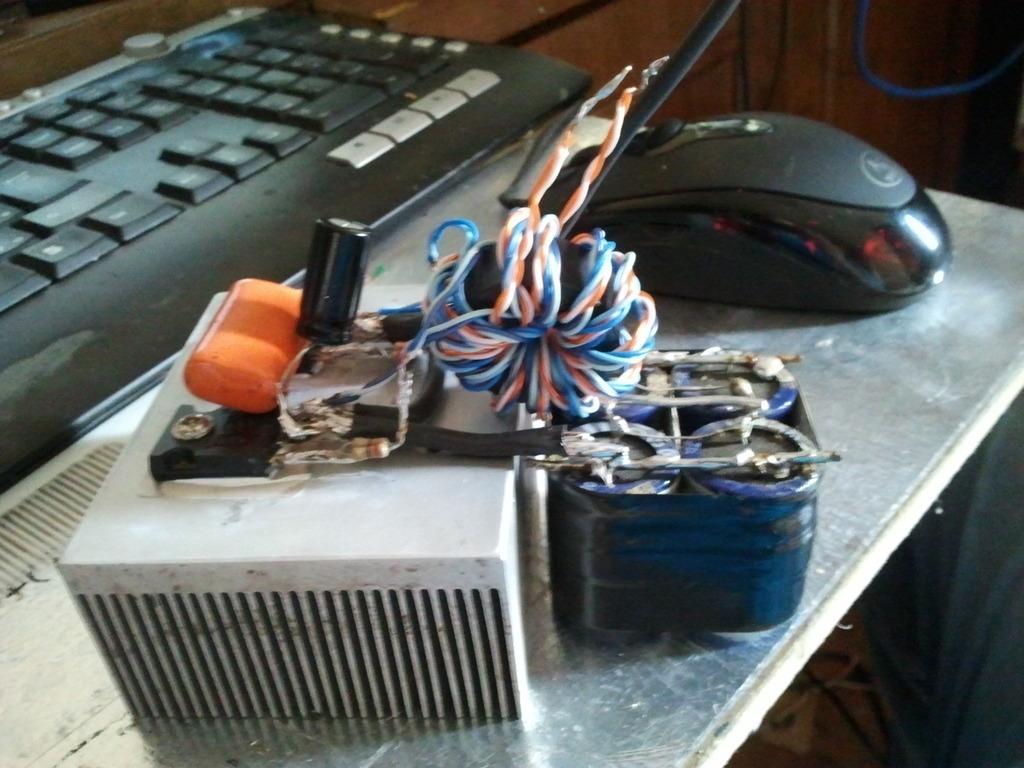Please provide a concise description of this image. In this image I can see a table which is silver in color and on the table I can see a black colored mouse, black colored keyboard and few other electronic equipment which is white, blue and black and orange in color. In the background I can see the wooden surface. 